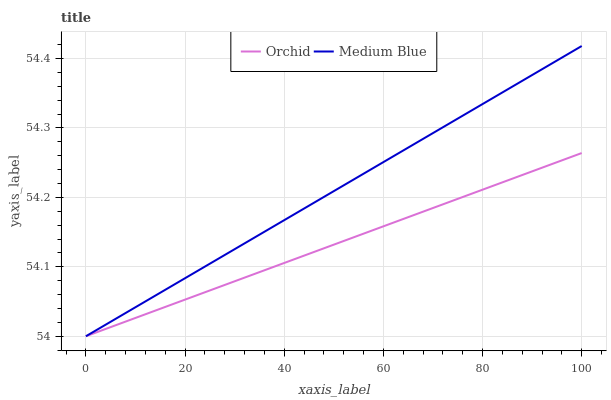Does Orchid have the maximum area under the curve?
Answer yes or no. No. Is Orchid the smoothest?
Answer yes or no. No. Does Orchid have the highest value?
Answer yes or no. No. 